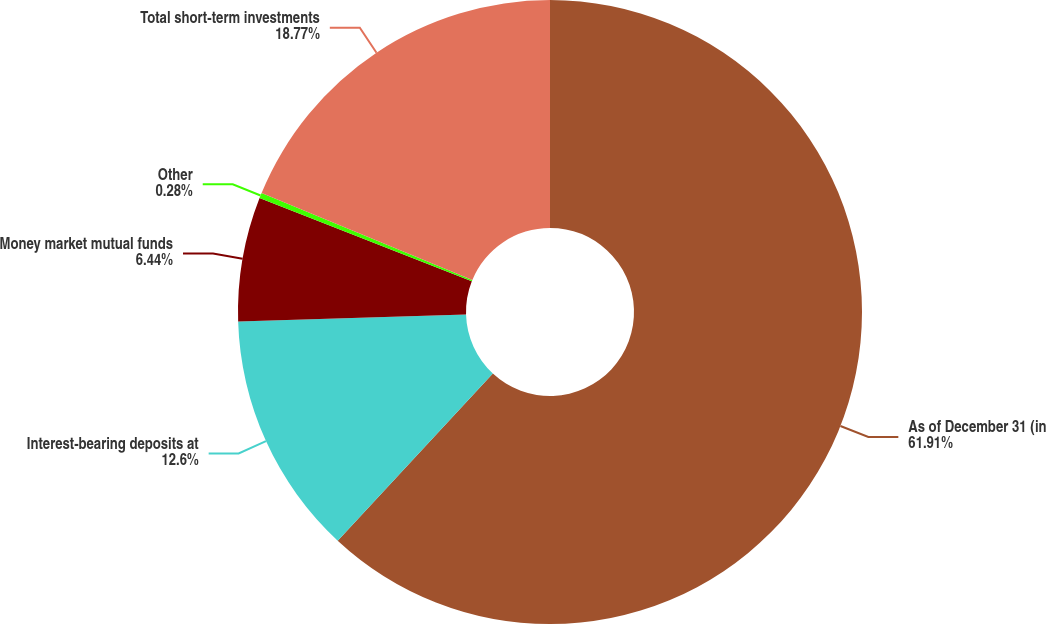<chart> <loc_0><loc_0><loc_500><loc_500><pie_chart><fcel>As of December 31 (in<fcel>Interest-bearing deposits at<fcel>Money market mutual funds<fcel>Other<fcel>Total short-term investments<nl><fcel>61.91%<fcel>12.6%<fcel>6.44%<fcel>0.28%<fcel>18.77%<nl></chart> 